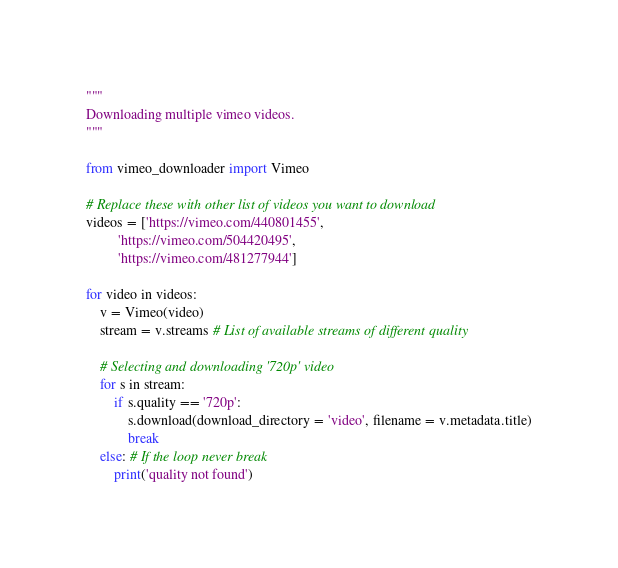Convert code to text. <code><loc_0><loc_0><loc_500><loc_500><_Python_>""" 
Downloading multiple vimeo videos.
"""

from vimeo_downloader import Vimeo

# Replace these with other list of videos you want to download
videos = ['https://vimeo.com/440801455',
		 'https://vimeo.com/504420495',
		 'https://vimeo.com/481277944']

for video in videos:
	v = Vimeo(video)
	stream = v.streams # List of available streams of different quality

	# Selecting and downloading '720p' video
	for s in stream:
		if s.quality == '720p': 
			s.download(download_directory = 'video', filename = v.metadata.title)
			break
	else: # If the loop never break
		print('quality not found')</code> 